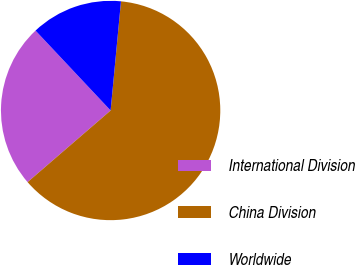Convert chart. <chart><loc_0><loc_0><loc_500><loc_500><pie_chart><fcel>International Division<fcel>China Division<fcel>Worldwide<nl><fcel>24.32%<fcel>62.16%<fcel>13.51%<nl></chart> 